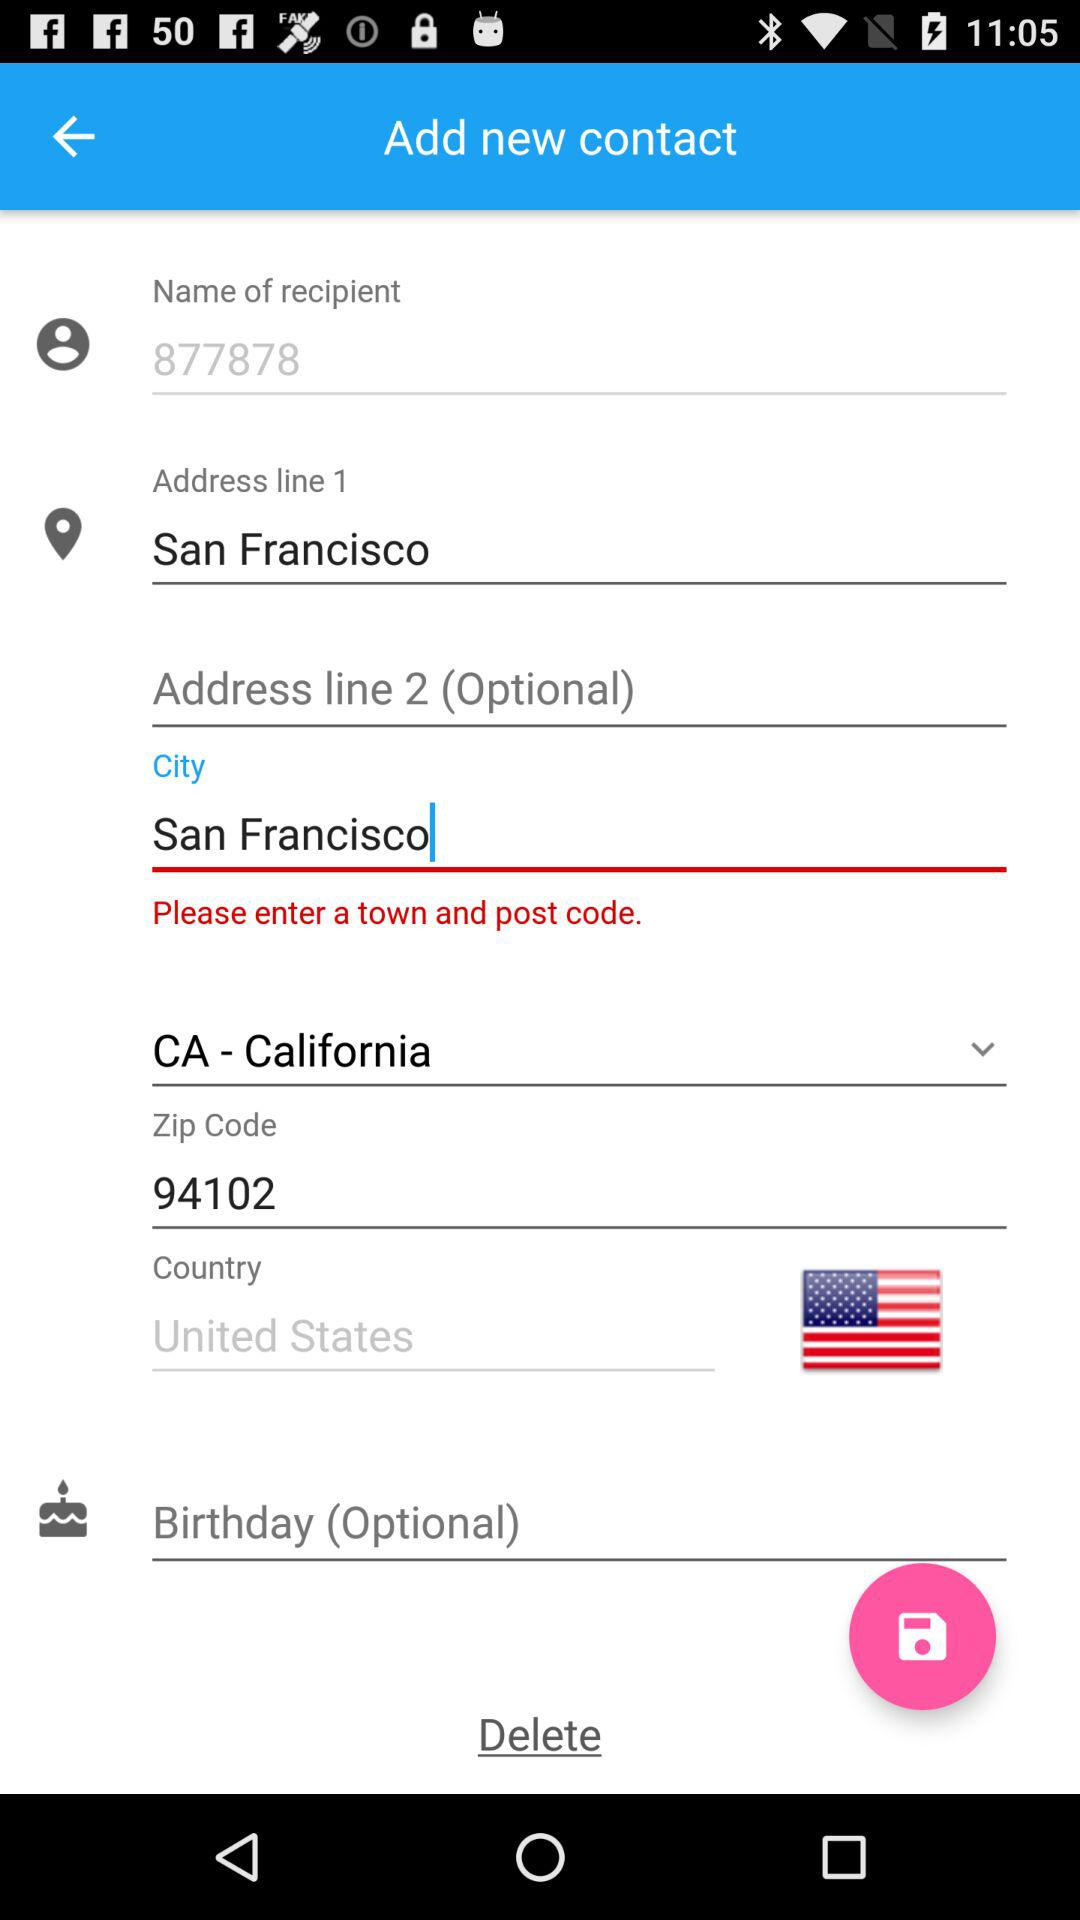What exactly does CA stand for? CA stands for California. 